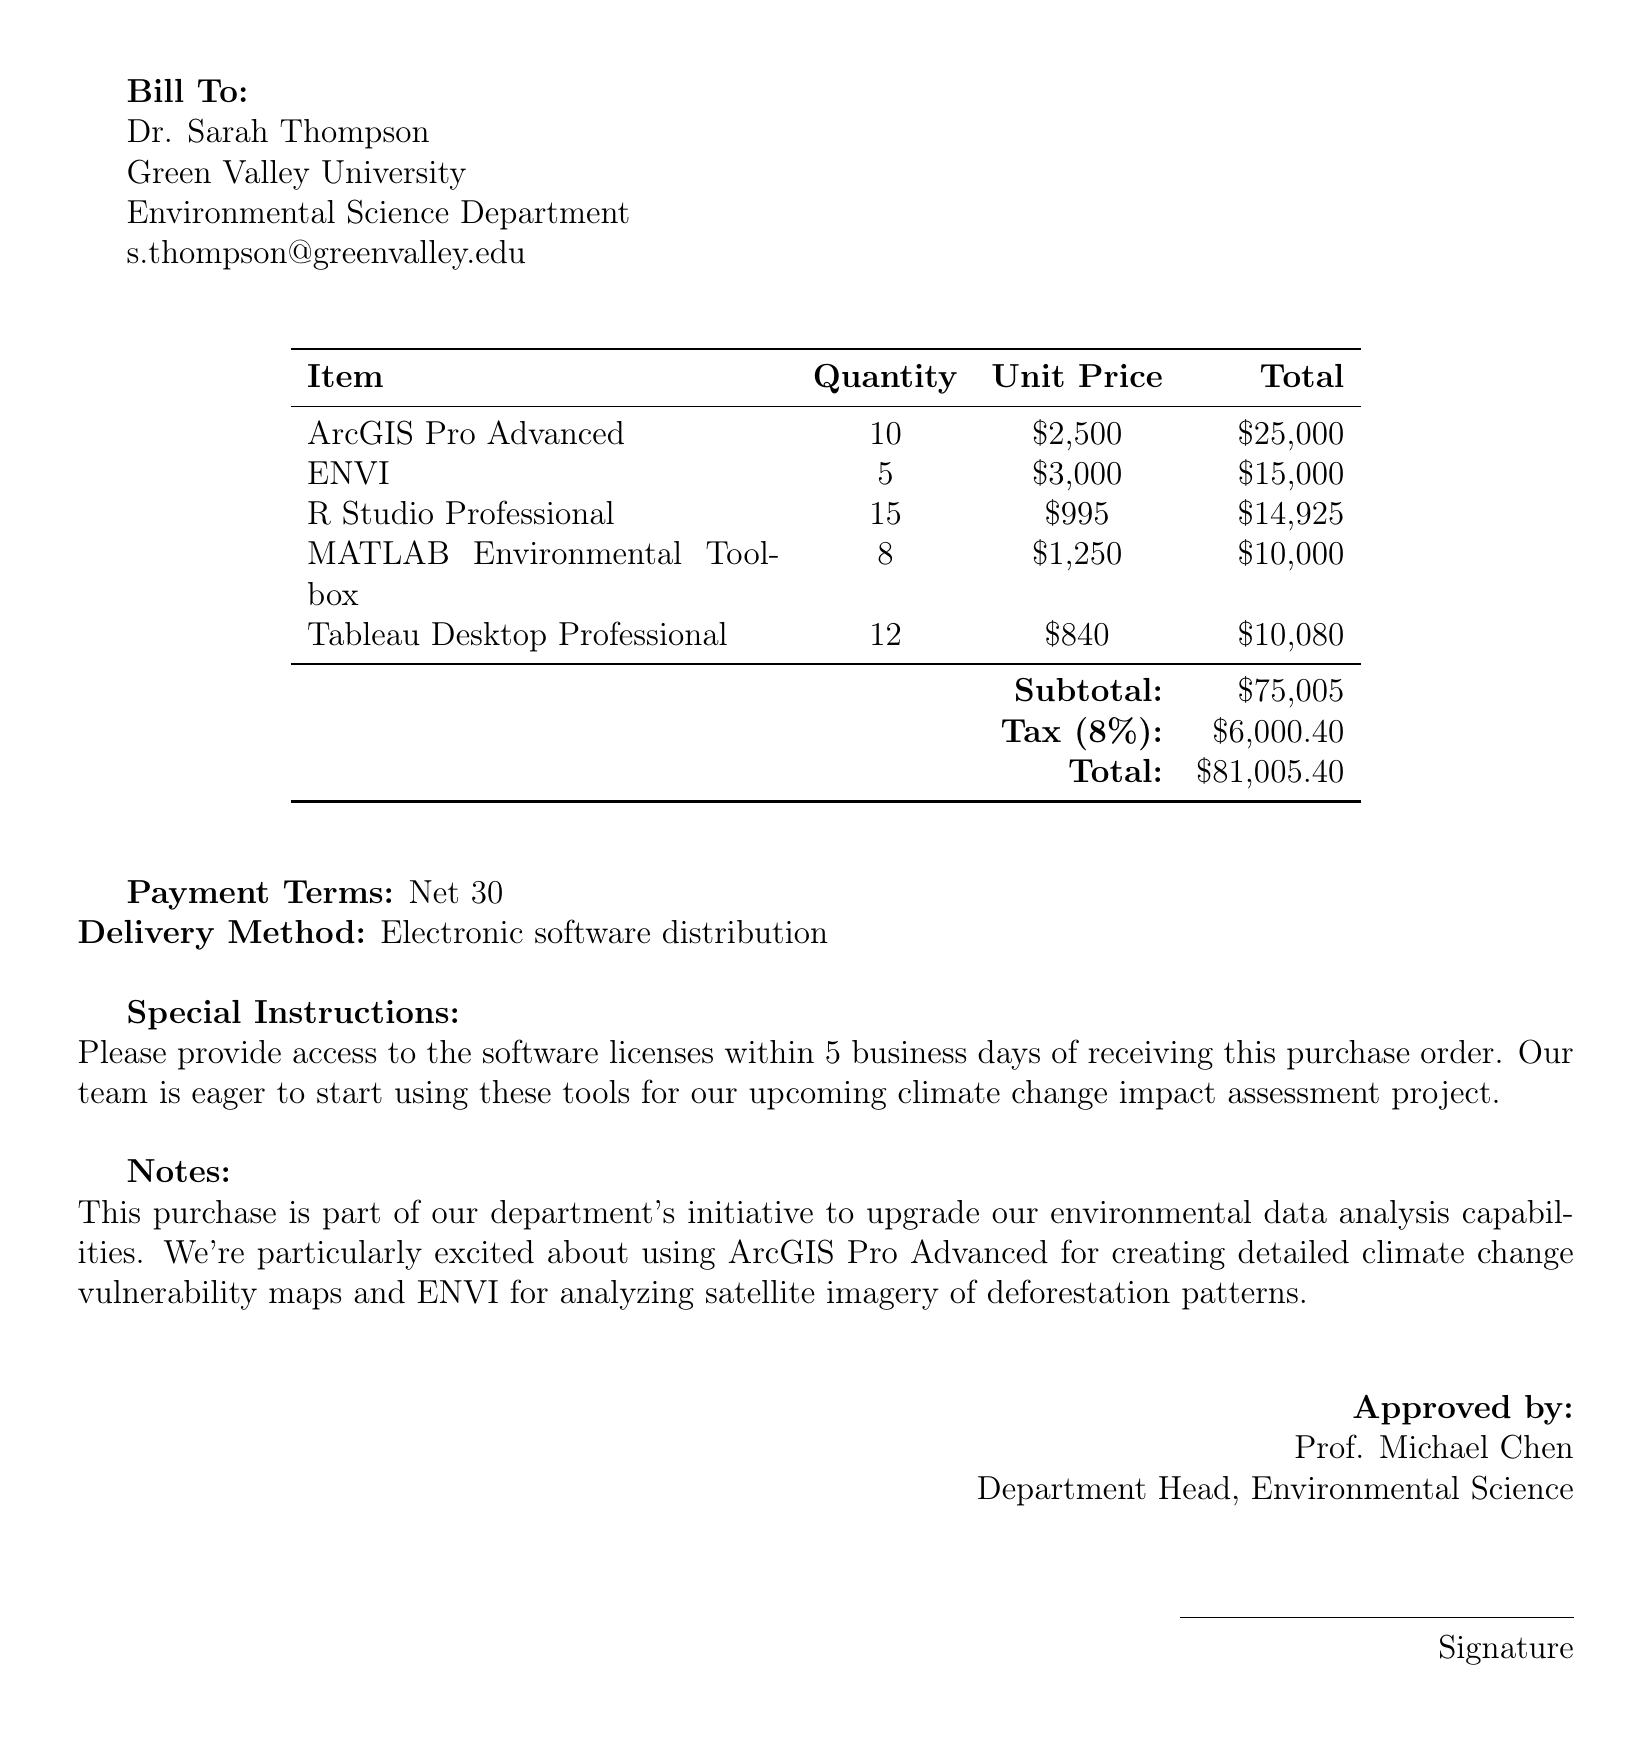What is the purchase order number? The purchase order number is the unique identifier for this transaction, which is PO-2023-0542.
Answer: PO-2023-0542 Who is the buyer? The buyer's information includes their name, institution, and department, specifically Dr. Sarah Thompson from Green Valley University, Environmental Science.
Answer: Dr. Sarah Thompson What is the total amount due? The total amount is the final sum owed for the purchase, which is calculated after taxes, amounting to 81,005.40.
Answer: 81,005.40 How many units of ENVI were purchased? The quantity of ENVI software licenses ordered can be found in the itemized list, which shows 5 units.
Answer: 5 What is the tax rate applied to the purchase? The tax rate is stated in the document and is 8%, which influences the calculated tax amount for the purchase.
Answer: 8% What is the special instruction regarding software delivery? Special instructions regarding the software delivery can be found in the document, which specifies a request for access within 5 business days.
Answer: Within 5 business days What is the payment term stated? The document specifies the payment terms, indicating that payment is due on a Net 30 basis.
Answer: Net 30 Which software is highlighted for creating climate change vulnerability maps? The document mentions that ArcGIS Pro Advanced is particularly aimed at creating detailed climate change vulnerability maps, giving insight into its intended use.
Answer: ArcGIS Pro Advanced 